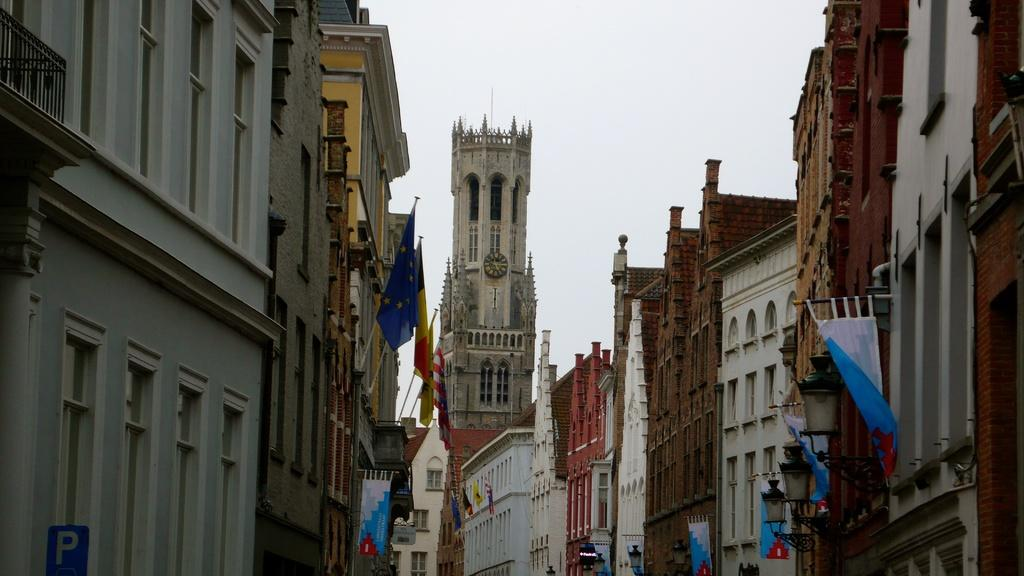What type of structures are present in the image? There are buildings in the image. What decorative elements can be seen on the buildings? There are flags on the buildings. What is visible at the top of the image? The sky is visible at the top of the image. What type of development is currently underway in the image? There is no indication of any development or construction in progress in the image. Has the design of the buildings in the image been approved by the local authorities? There is no information provided about the approval status of the buildings in the image. 